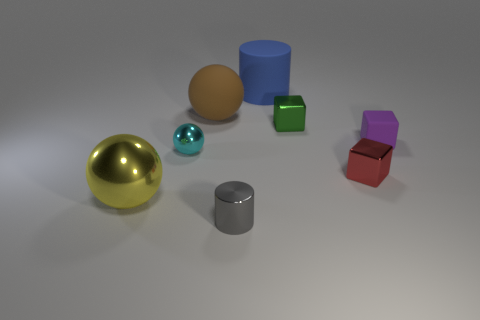There is a sphere that is both on the right side of the yellow thing and in front of the small purple rubber cube; what material is it?
Provide a succinct answer. Metal. Are there any tiny metallic cubes that are left of the tiny metal thing that is to the left of the cylinder that is in front of the big blue rubber object?
Your response must be concise. No. How many other things are the same size as the gray cylinder?
Your response must be concise. 4. There is a small cyan metallic sphere; are there any brown rubber objects on the right side of it?
Keep it short and to the point. Yes. Do the tiny shiny sphere and the large rubber object that is to the left of the large matte cylinder have the same color?
Ensure brevity in your answer.  No. What is the color of the big sphere in front of the matte object that is on the left side of the cylinder that is in front of the small green cube?
Give a very brief answer. Yellow. Are there any big metallic things that have the same shape as the tiny gray metal thing?
Provide a succinct answer. No. The matte sphere that is the same size as the yellow shiny thing is what color?
Ensure brevity in your answer.  Brown. There is a large thing in front of the tiny rubber block; what material is it?
Provide a succinct answer. Metal. There is a large rubber object to the left of the small gray thing; is it the same shape as the large object in front of the cyan shiny object?
Make the answer very short. Yes. 